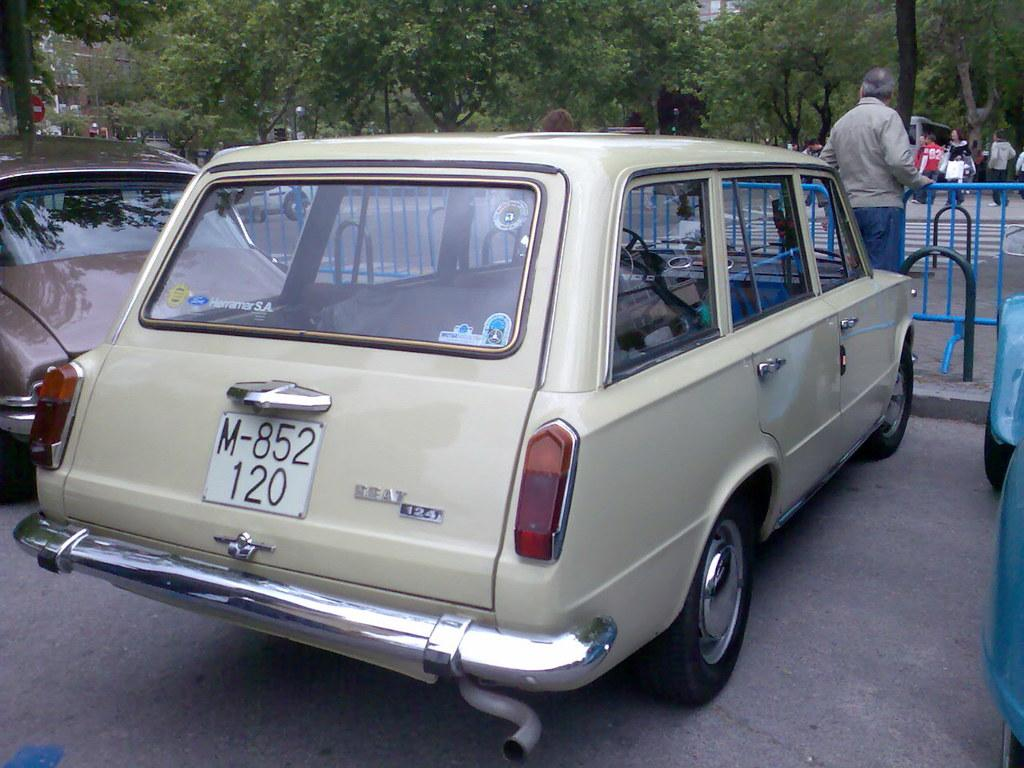What type of vehicles can be seen on the ground in the image? There are cars on the ground in the image. What is the purpose of the fencing in the image? The purpose of the fencing in the image is not explicitly stated, but it could be for safety or to mark boundaries. How many groups of people are visible in the image? There are groups of people standing in the image. What type of pedestrian crossing is present in the image? There is a zebra crossing in the image. What can be seen in the background of the image? There are many trees visible in the background of the image. Where is the cushion placed in the image? There is no cushion present in the image. How many bikes are visible in the image? There are no bikes visible in the image. 